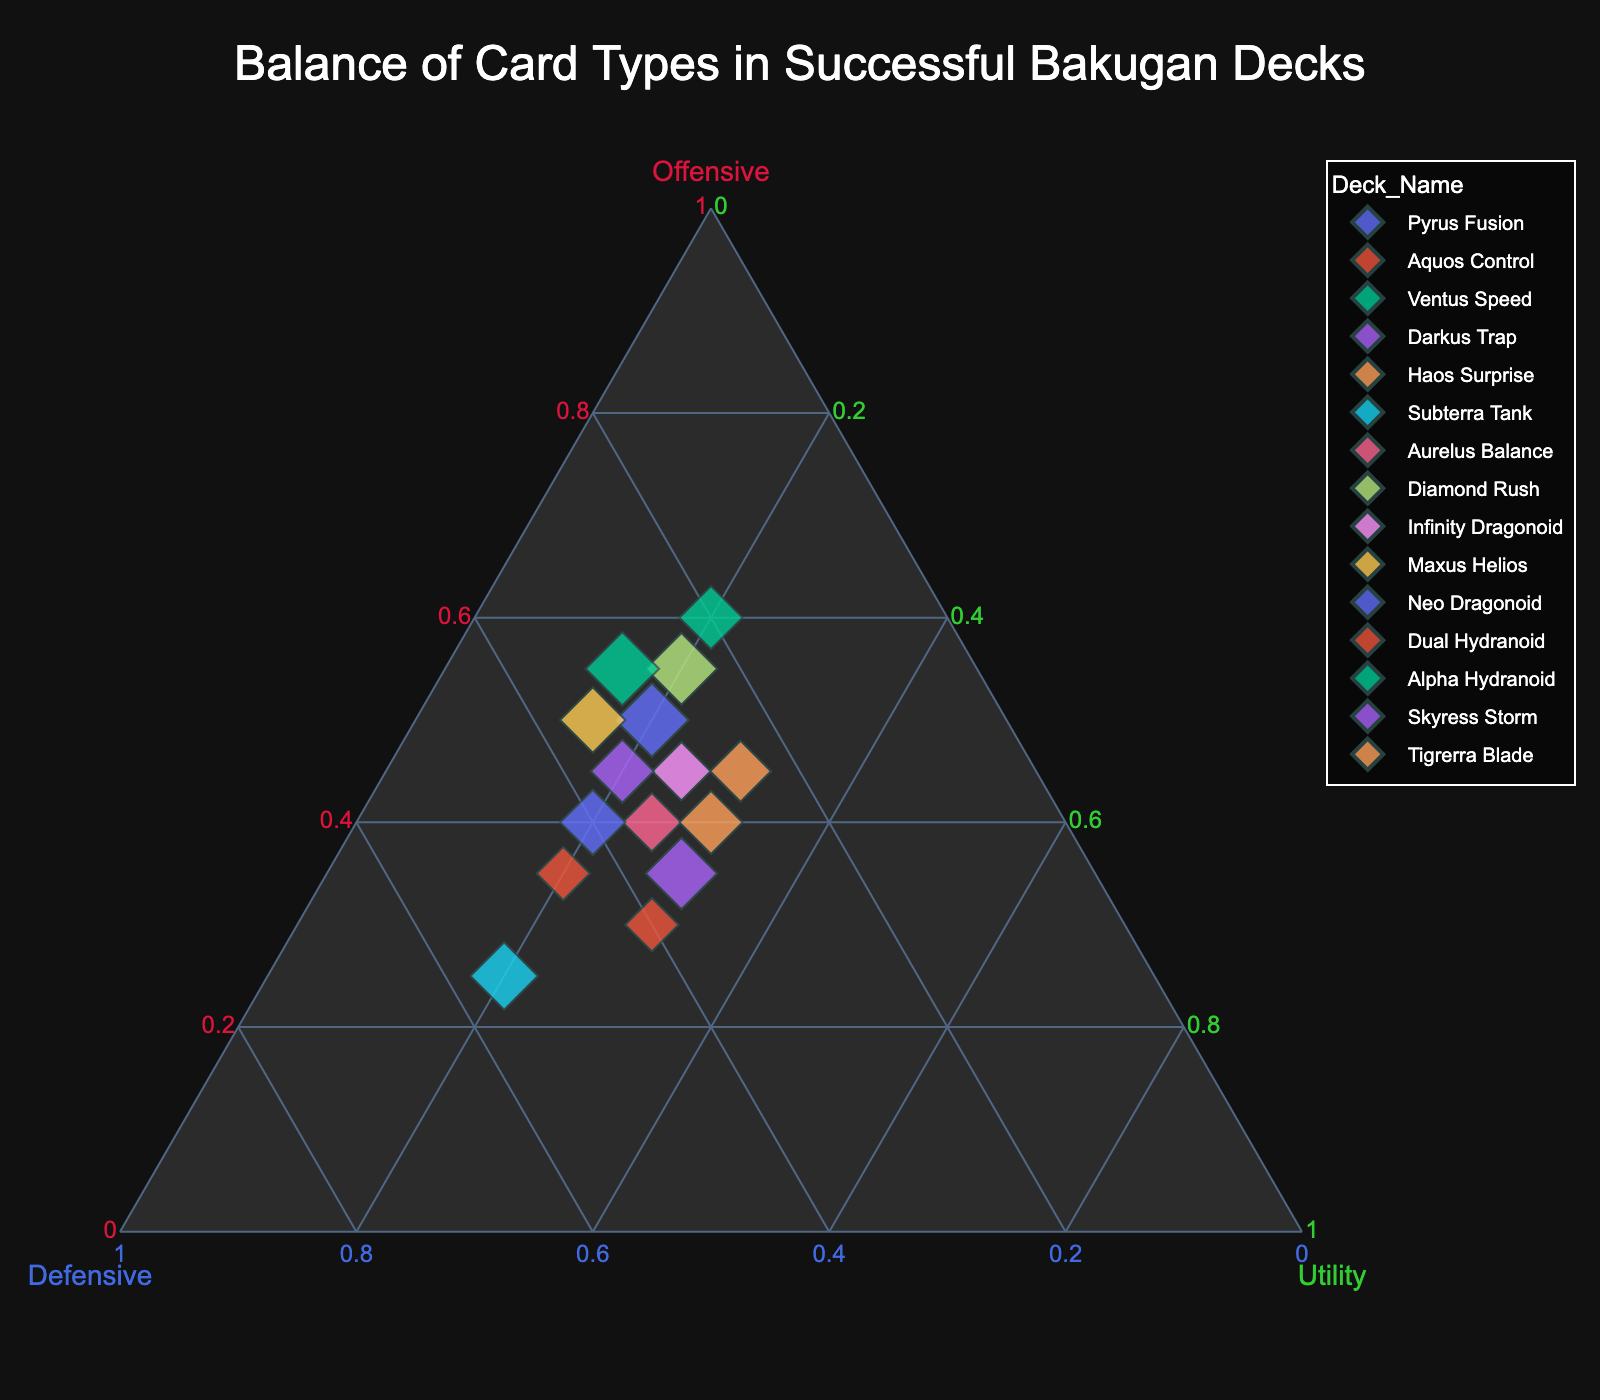What's the title of the figure? The title is usually displayed at the top of the figure. It provides a summary of what the chart is about.
Answer: Balance of Card Types in Successful Bakugan Decks What deck has the highest amount of Offensive cards? Look for the data point that is furthest along the Offensive axis (marked in crimson) and check the associated deck name.
Answer: Ventus Speed How many decks have an equal balance of Offensive and Defensive cards? Compare the Offensive and Defensive values for each deck and count how many are equal.
Answer: Two (Darkus Trap, Neo Dragonoid) Which deck has the highest amount of Utility cards? Find the data point that is the furthest along the Utility axis (marked in limegreen) and check the deck name.
Answer: Aquos Control What is the median percentage of Utility cards in these decks? List the Utility percentages, order them, and find the middle value.
Answer: 20 Which deck has the closest balance between all three card types? Look for a point near the center of the ternary plot, where all three values are close to each other.
Answer: Tigrerra Blade How many decks have a higher percentage of Defensive cards than Offensive cards? Compare Offensive and Defensive values for each deck and count how many decks have Defensive values higher than Offensive values.
Answer: Three (Aquos Control, Subterra Tank, Dual Hydranoid) Which deck has the lowest amount of Utility cards? Check each data point along the Utility axis and find the one with the lowest value.
Answer: Maxus Helios, Alpha Hydranoid Identify a unique pattern or trend visible in the ternary plot. One observable trend might be the variation in deck composition preferences among different successful decks. This can be identified by looking at how the data points are distributed across the three axes.
Answer: There's a preference for Offensive and Defensive cards over Utility cards Is there any correlation between the deck names and their preferred card types? Analyze the positions of data points along the Offensive, Defensive, and Utility axes and see if there is a pattern based on the deck names.
Answer: Certain decks like "Ventus Speed" and "Pyrus Fusion" tend to favor more Offensive cards 